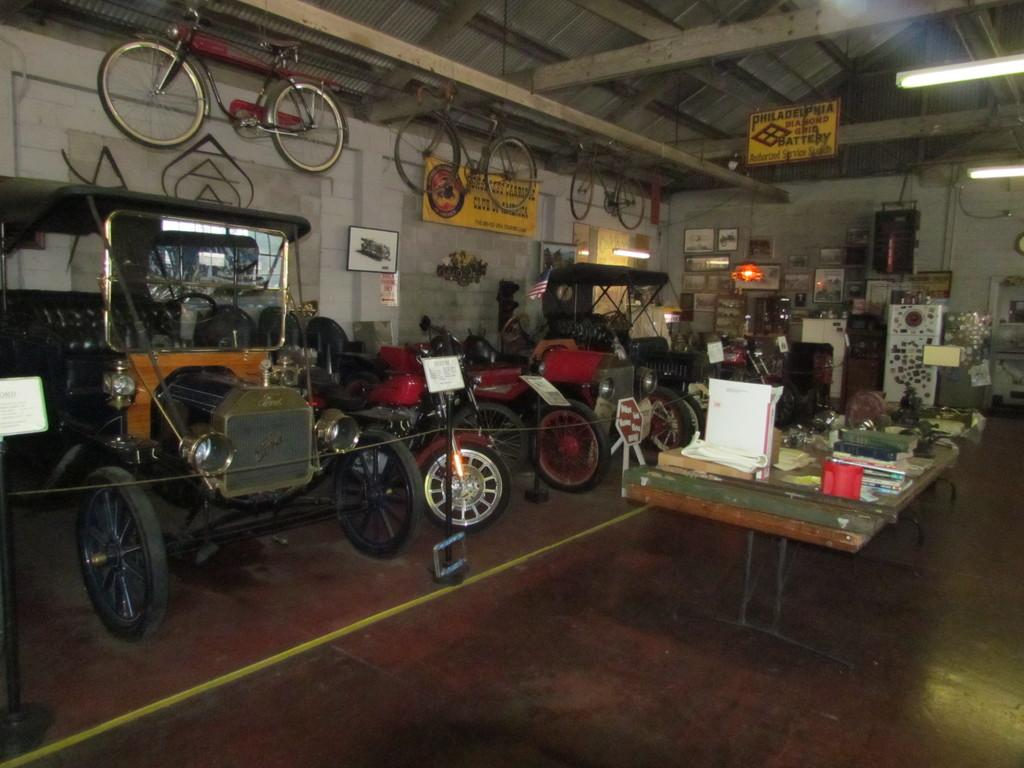What types of transportation are present in the image? There are vehicles and bicycles in the image. How are the vehicles positioned in the image? The vehicles are parked on the floor. How are the bicycles positioned in the image? The bicycles are hanging from the top. What type of insurance is required for the surprise in the image? There is no surprise present in the image, so no insurance is required. 